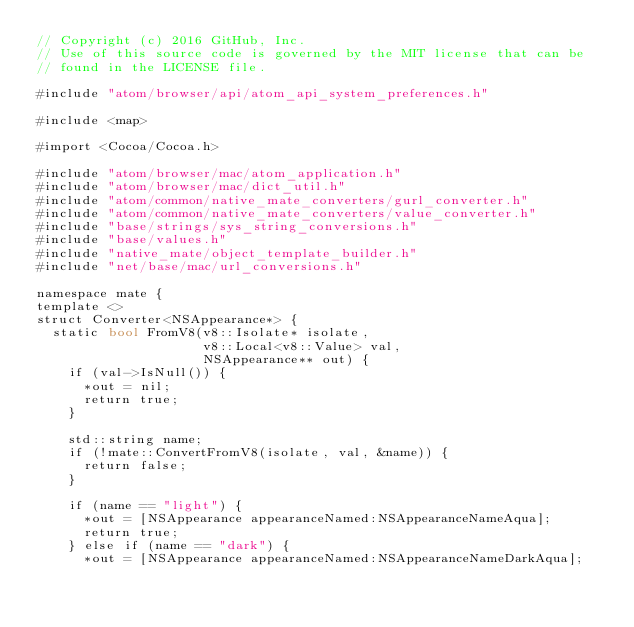<code> <loc_0><loc_0><loc_500><loc_500><_ObjectiveC_>// Copyright (c) 2016 GitHub, Inc.
// Use of this source code is governed by the MIT license that can be
// found in the LICENSE file.

#include "atom/browser/api/atom_api_system_preferences.h"

#include <map>

#import <Cocoa/Cocoa.h>

#include "atom/browser/mac/atom_application.h"
#include "atom/browser/mac/dict_util.h"
#include "atom/common/native_mate_converters/gurl_converter.h"
#include "atom/common/native_mate_converters/value_converter.h"
#include "base/strings/sys_string_conversions.h"
#include "base/values.h"
#include "native_mate/object_template_builder.h"
#include "net/base/mac/url_conversions.h"

namespace mate {
template <>
struct Converter<NSAppearance*> {
  static bool FromV8(v8::Isolate* isolate,
                     v8::Local<v8::Value> val,
                     NSAppearance** out) {
    if (val->IsNull()) {
      *out = nil;
      return true;
    }

    std::string name;
    if (!mate::ConvertFromV8(isolate, val, &name)) {
      return false;
    }

    if (name == "light") {
      *out = [NSAppearance appearanceNamed:NSAppearanceNameAqua];
      return true;
    } else if (name == "dark") {
      *out = [NSAppearance appearanceNamed:NSAppearanceNameDarkAqua];</code> 